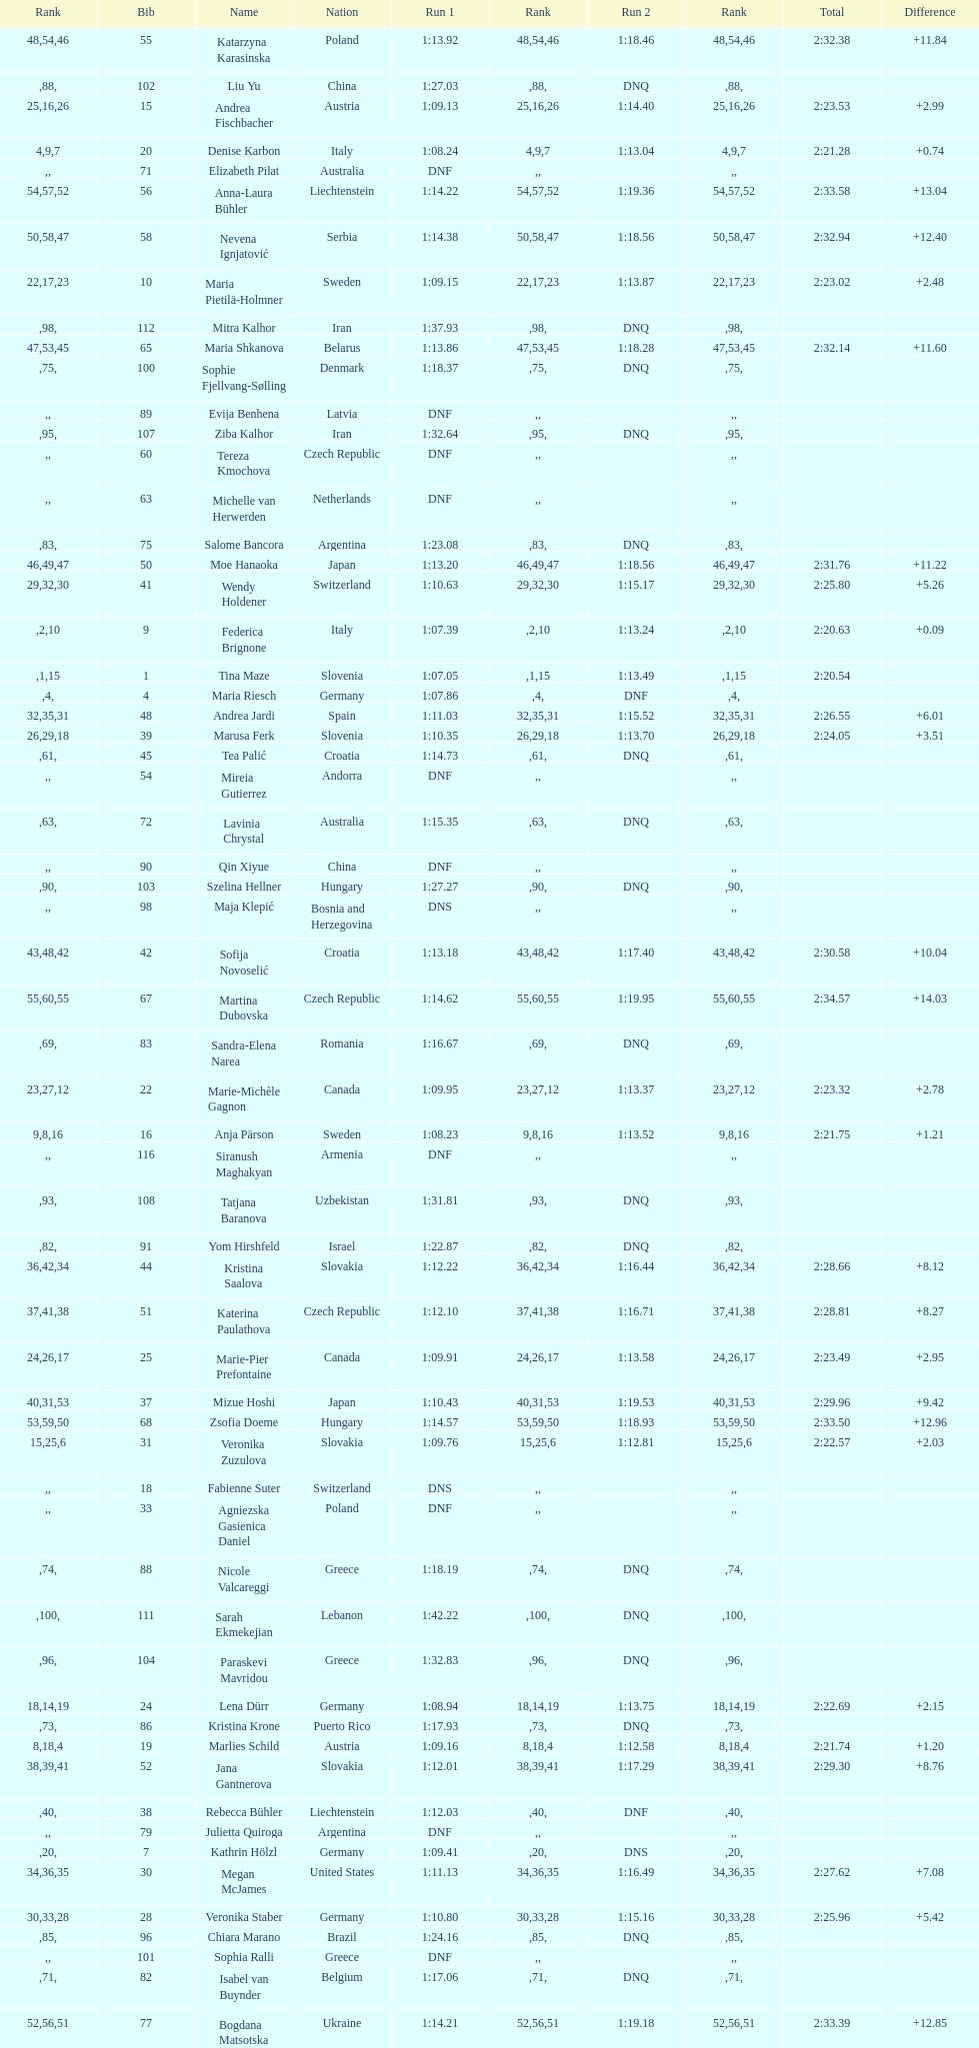How many italians finished in the top ten? 3. 